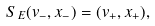Convert formula to latex. <formula><loc_0><loc_0><loc_500><loc_500>S _ { E } ( v _ { - } , x _ { - } ) = ( v _ { + } , x _ { + } ) ,</formula> 